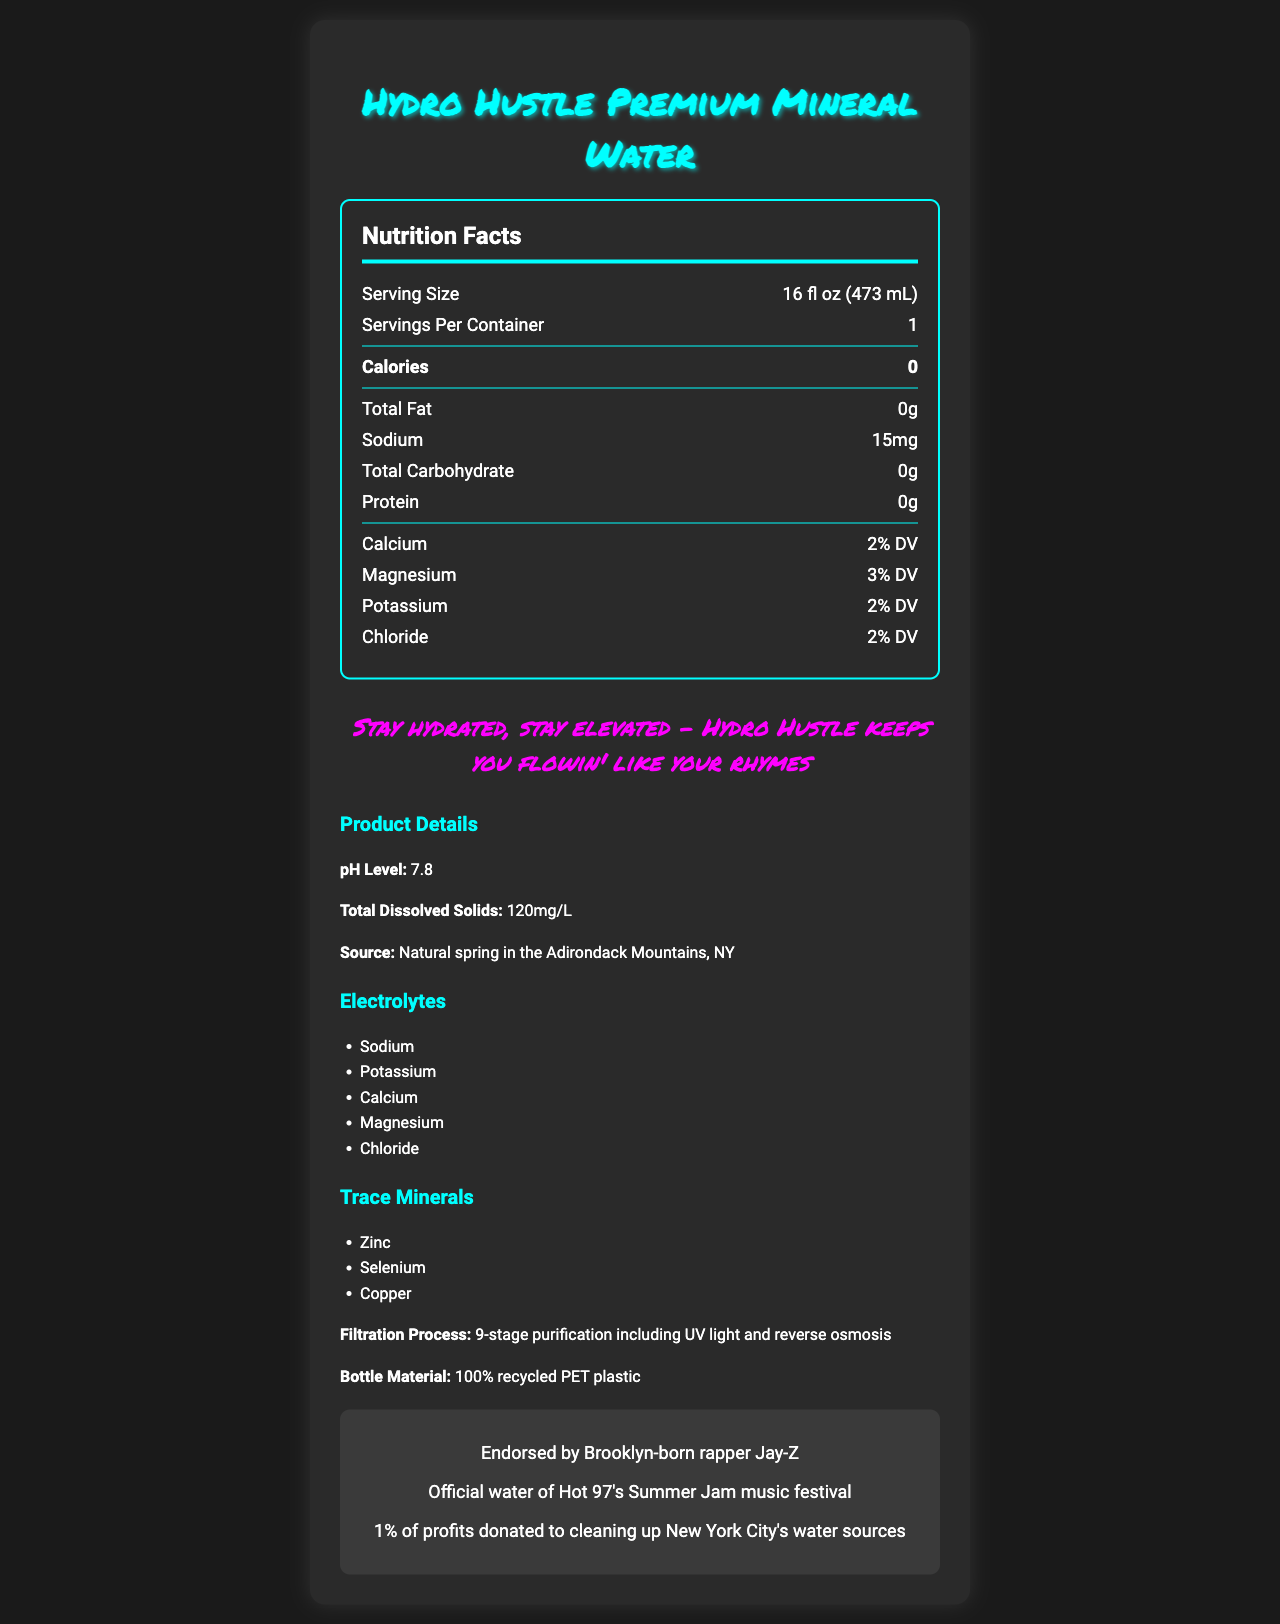what is the serving size? The serving size is mentioned as "16 fl oz (473 mL)" in the nutrition facts section.
Answer: 16 fl oz (473 mL) how much sodium does Hydro Hustle Premium Mineral Water contain per serving? The sodium content is listed as "15mg" in the nutrition facts section.
Answer: 15mg what is the calcium daily value percentage? The calcium daily value percentage is stated as "2% DV" in the nutrition facts section.
Answer: 2% what is the source of the water? The source of the water is mentioned as "Natural spring in the Adirondack Mountains, NY" in the additional info section.
Answer: Natural spring in the Adirondack Mountains, NY what is the total dissolved solids measurement? The total dissolved solids are listed as "120mg/L" in the additional info section.
Answer: 120mg/L what is the ph level of Hydro Hustle Premium Mineral Water? The pH level is mentioned as "7.8" in the additional info section.
Answer: 7.8 how many servings are there per container? The servings per container are listed as "1" in the nutrition facts section.
Answer: 1 which minerals are present as trace minerals? A. Zinc, Selenium, Copper B. Iron, Calcium, Magnesium C. Potassium, Sodium, Chloride The trace minerals are listed in the additional info section as "Zinc, Selenium, Copper".
Answer: A. Zinc, Selenium, Copper what is the slogan of Hydro Hustle Premium Mineral Water? A. Stay Fresh B. Hustle Harder C. Stay Hydrated, Stay Elevated The rap-inspired slogan is mentioned in the document as "Stay hydrated, stay elevated - Hydro Hustle keeps you flowin' like your rhymes".
Answer: C. Stay Hydrated, Stay Elevated is this product endorsed by a celebrity? The endorsement by Jay-Z is highlighted in the additional info section.
Answer: Yes what is the total amount of protein in this water? The protein content is listed as "0g" in the nutrition facts section.
Answer: 0g how many stages are involved in the filtration process? The filtration process is described as involving "9-stage purification" including UV light and reverse osmosis in the additional info section.
Answer: 9 summarize the main idea of the document. The document emphasizes the hydration benefits, quality, and brand appeal of Hydro Hustle Premium Mineral Water, targeted at health-conscious hip-hop enthusiasts.
Answer: The document presents the nutrition facts and additional details of Hydro Hustle Premium Mineral Water, highlighting its zero-calorie content, presence of essential minerals and electrolytes, natural spring source, eco-friendly bottle material, purification process, and endorsements by high-profile figures in the music industry. what is the flavor description of Hydro Hustle Premium Mineral Water? The flavor description is provided towards the end of the additional info section.
Answer: Smooth, crisp taste with a subtle mineral finish that complements the urban hustle what is the target audience for Hydro Hustle Premium Mineral Water? The target audience is stated in the additional info section as "Health-conscious hip-hop enthusiasts and aspiring artists in the NYC metro area".
Answer: Health-conscious hip-hop enthusiasts and aspiring artists in the NYC metro area how much total fat does this product contain? The total fat content is listed as "0g" in the nutrition facts section.
Answer: 0g how much profit is donated to eco-friendly initiatives? The eco-friendly initiative mentions that "1% of profits" are donated to cleaning up New York City's water sources.
Answer: 1% is it mentioned how the minerals and electrolytes are derived? The document does not specify how the minerals and electrolytes are derived, only stating their presence and daily value percentages.
Answer: Not enough information 